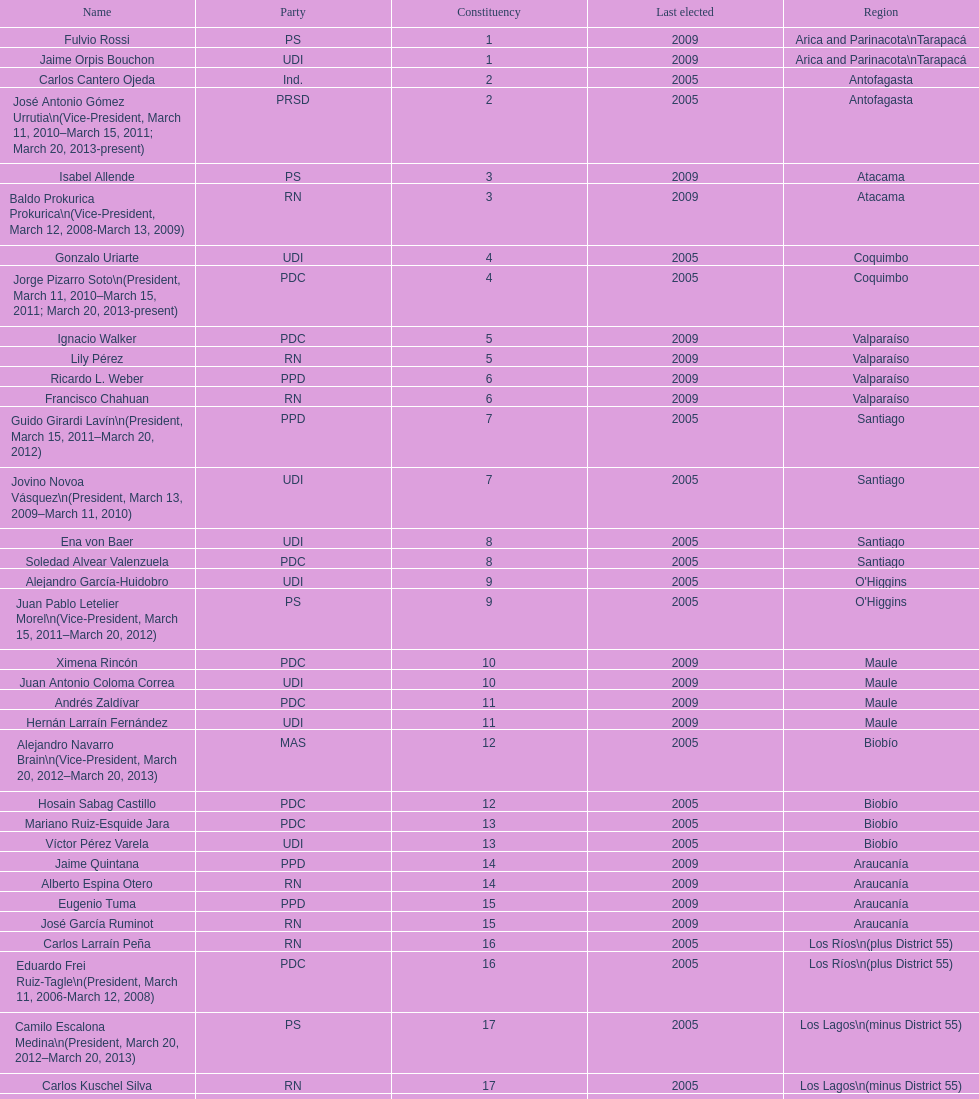How many total consituency are listed in the table? 19. 